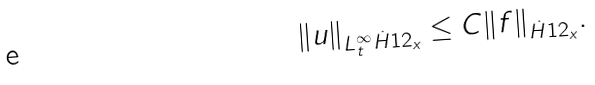Convert formula to latex. <formula><loc_0><loc_0><loc_500><loc_500>\| u \| _ { L ^ { \infty } _ { t } \dot { H } ^ { } { 1 } 2 _ { x } } \leq C \| f \| _ { \dot { H } ^ { } { 1 } 2 _ { x } } .</formula> 